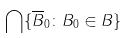Convert formula to latex. <formula><loc_0><loc_0><loc_500><loc_500>\bigcap \{ \overline { B } _ { 0 } \colon B _ { 0 } \in B \}</formula> 